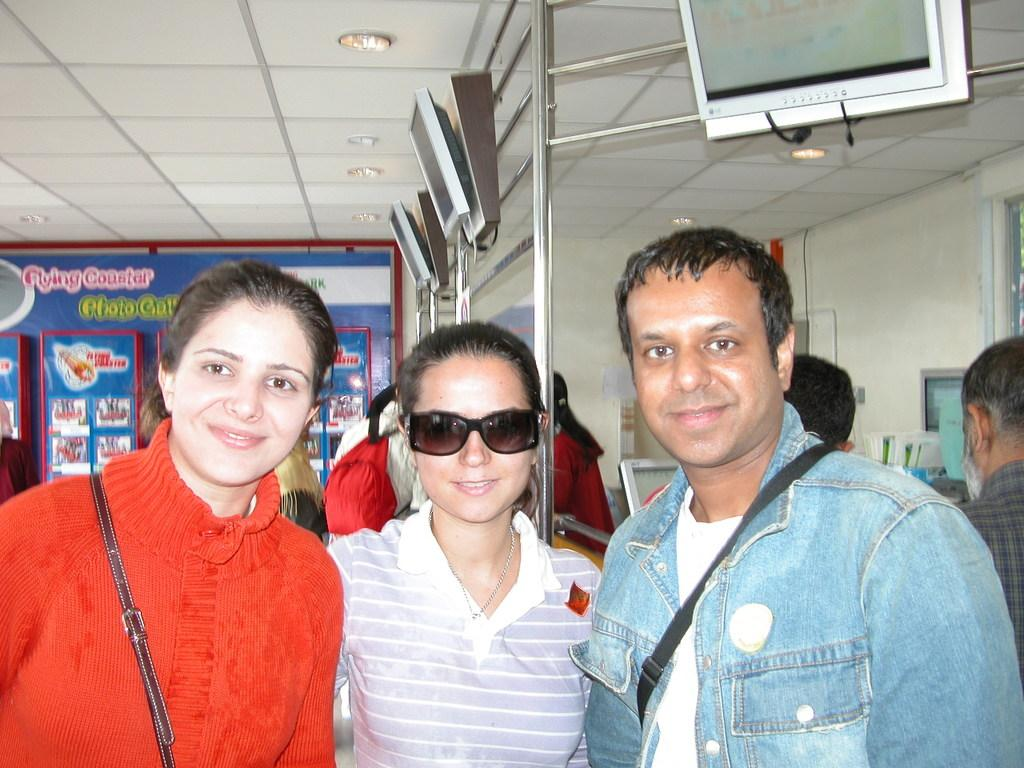What is the gender of the person on the left side of the image? There is a woman on the left side of the image. What is the woman wearing on her upper body? The woman is wearing a red color sweater. What accessory is the woman wearing on her face? The woman is wearing spectacles. What is the gender of the person on the right side of the image? There is a man on the right side of the image. What is the man wearing on his upper body? The man is wearing a jeans shirt. What historical discovery is being made by the woman in the image? There is no indication of a historical discovery being made in the image; it simply shows a woman wearing a red sweater and spectacles. 